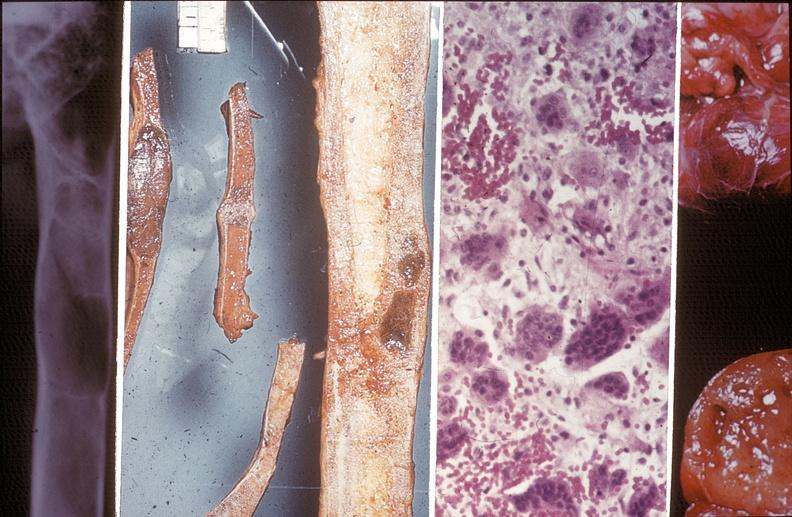what is present?
Answer the question using a single word or phrase. Joints 